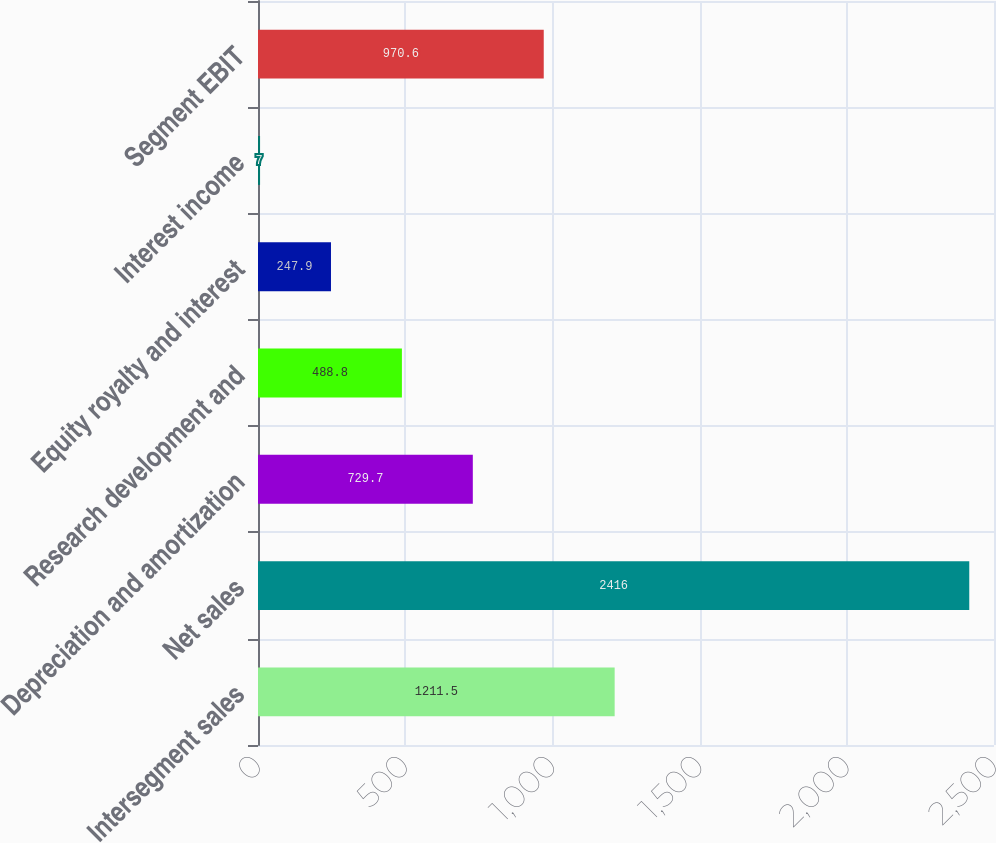<chart> <loc_0><loc_0><loc_500><loc_500><bar_chart><fcel>Intersegment sales<fcel>Net sales<fcel>Depreciation and amortization<fcel>Research development and<fcel>Equity royalty and interest<fcel>Interest income<fcel>Segment EBIT<nl><fcel>1211.5<fcel>2416<fcel>729.7<fcel>488.8<fcel>247.9<fcel>7<fcel>970.6<nl></chart> 